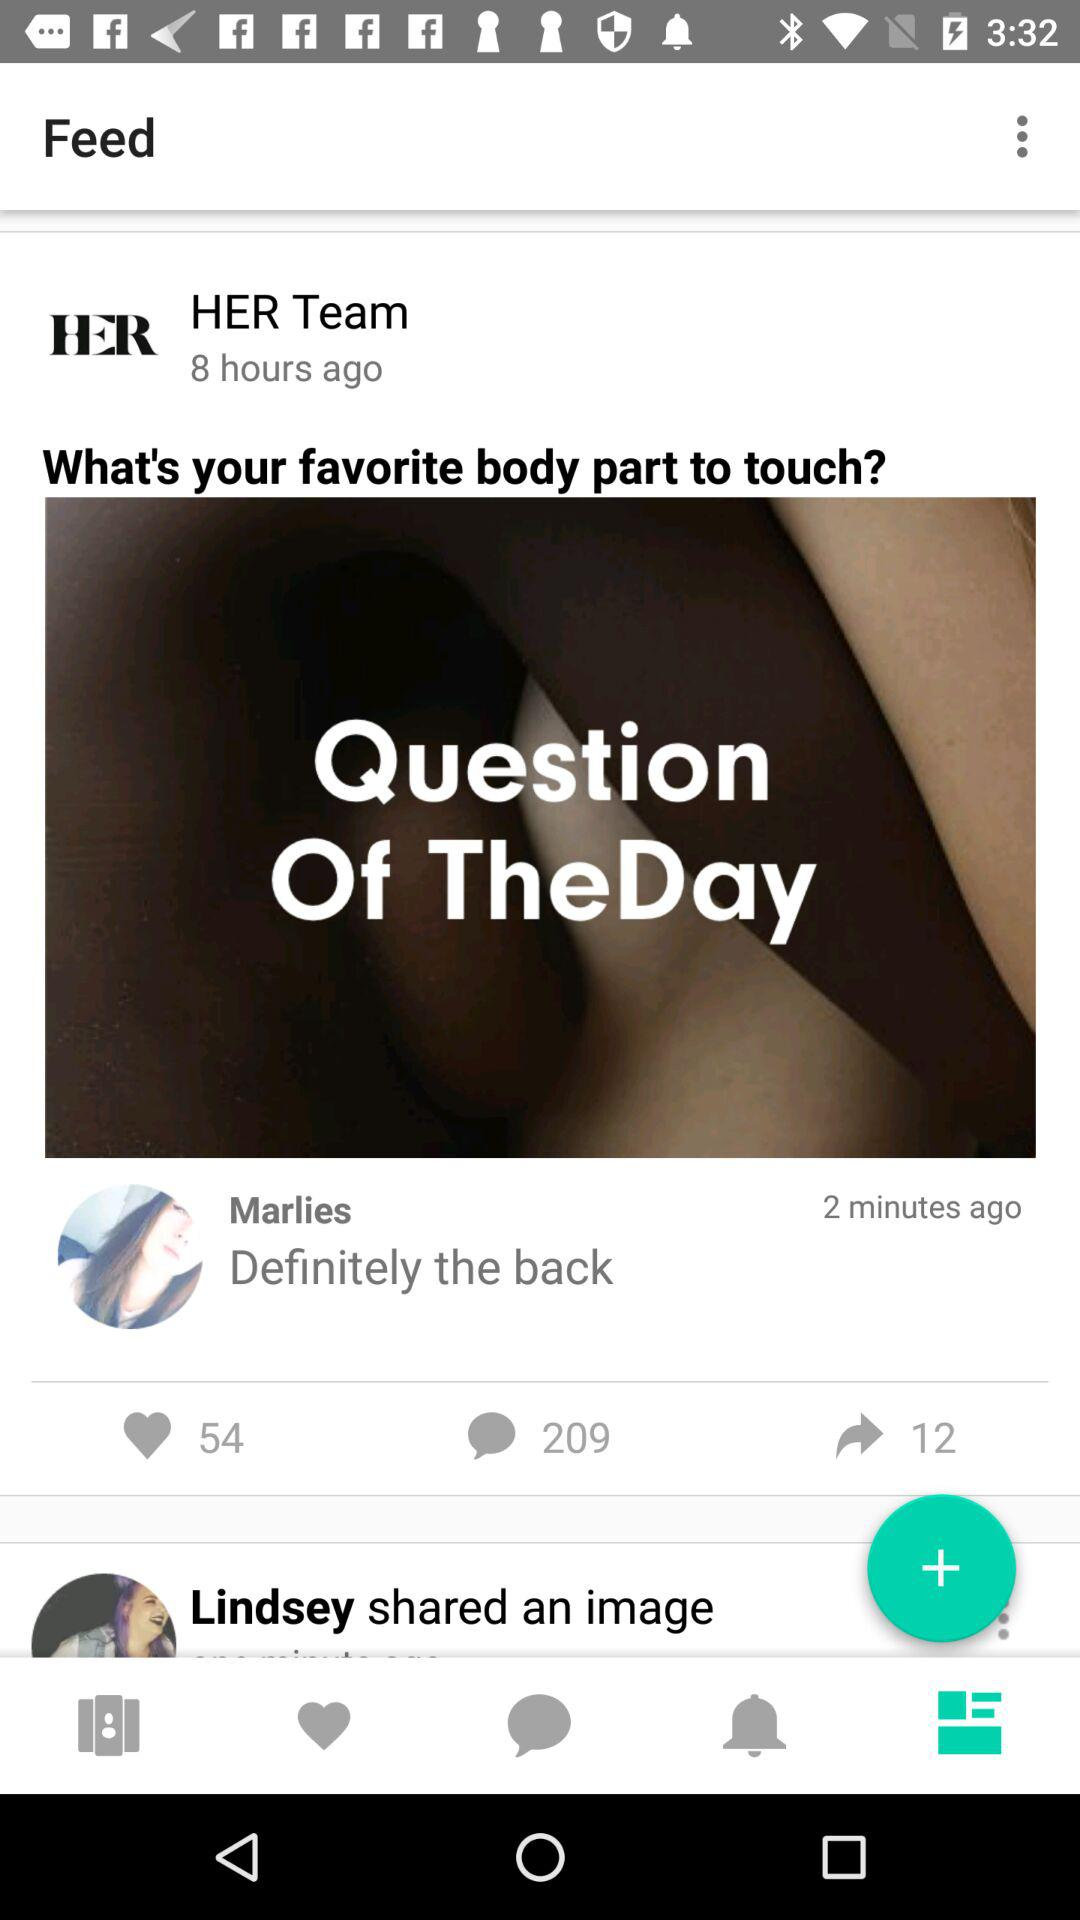What is the count of likes? The count of likes is 54. 